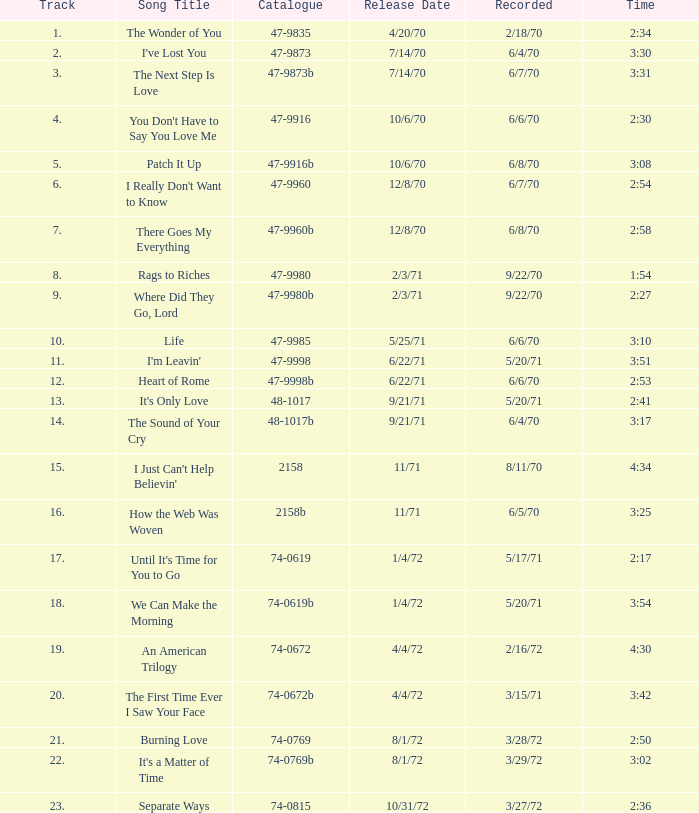What is Heart of Rome's catalogue number? 47-9998b. 